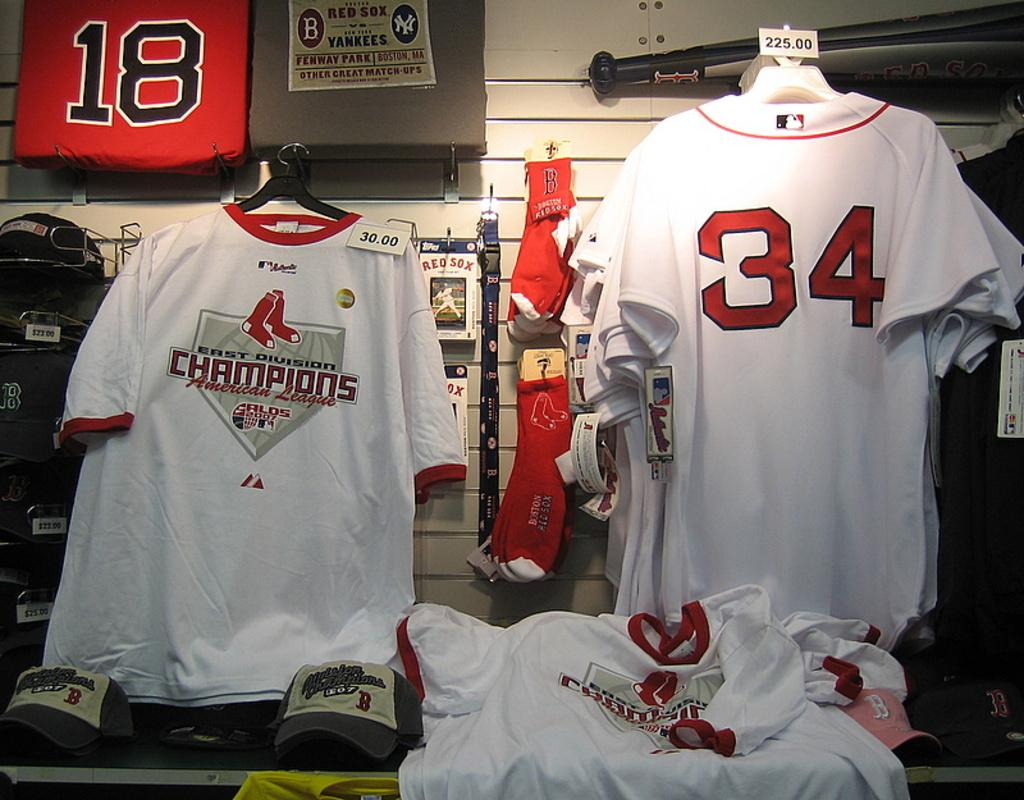<image>
Give a short and clear explanation of the subsequent image. White sports clothings hangs in a store below a sign with Red Sox and Yankees written on it. 